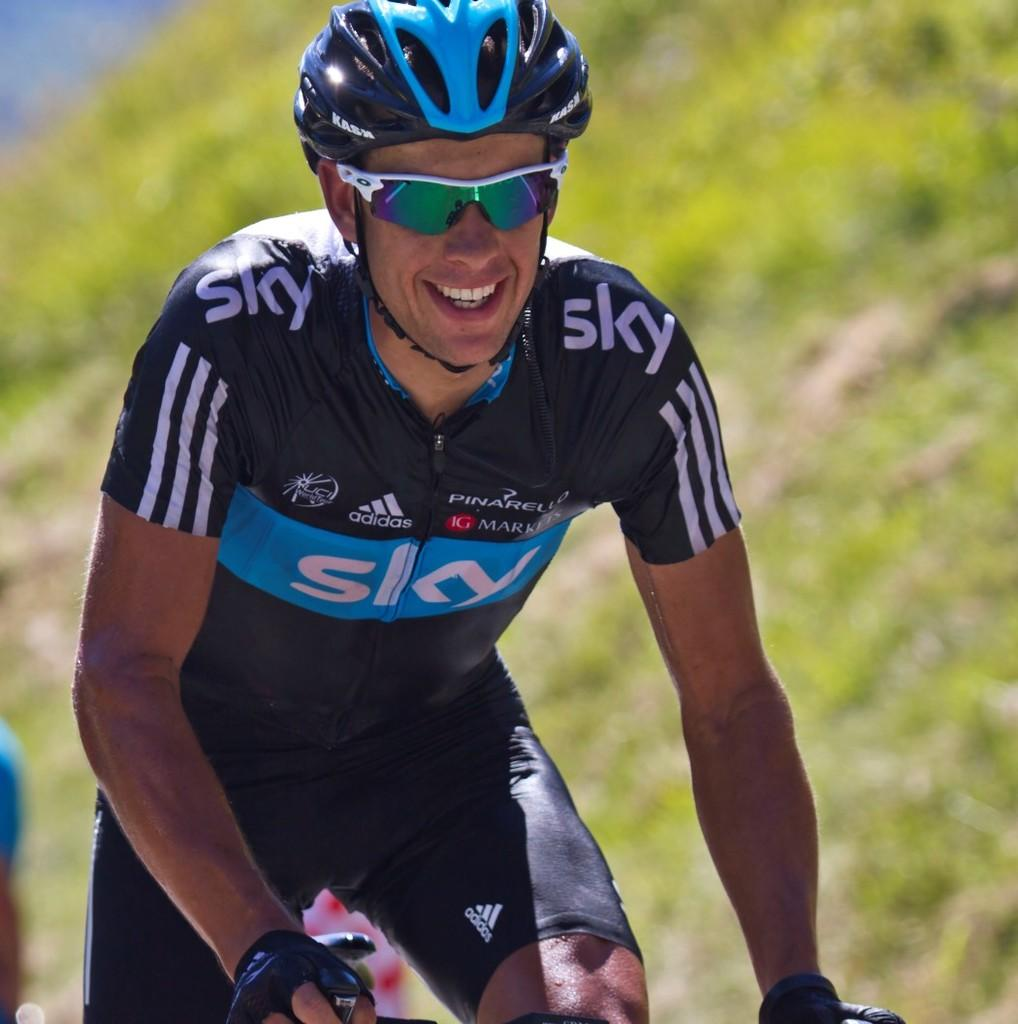Who is the main subject in the image? There is a man in the image. What is the man doing in the image? The man is riding a bicycle. What safety equipment is the man wearing in the image? The man is wearing a helmet, goggles, and gloves. What can be seen in the background of the image? There is grass in the background of the image. What team is the man talking to on his phone in the image? There is no phone visible in the image, and the man is not depicted as talking to anyone. 